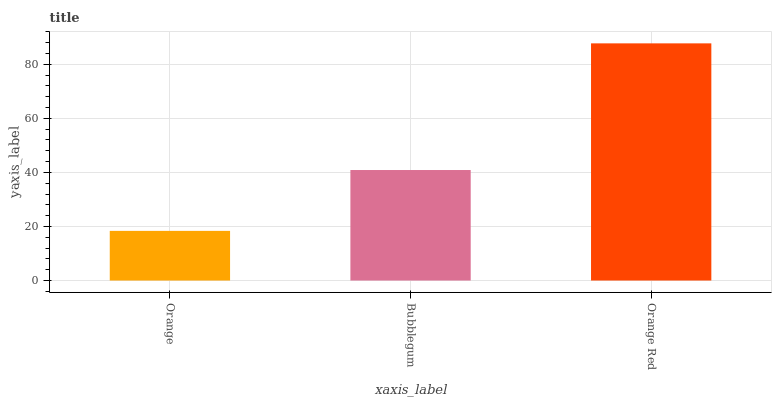Is Bubblegum the minimum?
Answer yes or no. No. Is Bubblegum the maximum?
Answer yes or no. No. Is Bubblegum greater than Orange?
Answer yes or no. Yes. Is Orange less than Bubblegum?
Answer yes or no. Yes. Is Orange greater than Bubblegum?
Answer yes or no. No. Is Bubblegum less than Orange?
Answer yes or no. No. Is Bubblegum the high median?
Answer yes or no. Yes. Is Bubblegum the low median?
Answer yes or no. Yes. Is Orange Red the high median?
Answer yes or no. No. Is Orange Red the low median?
Answer yes or no. No. 